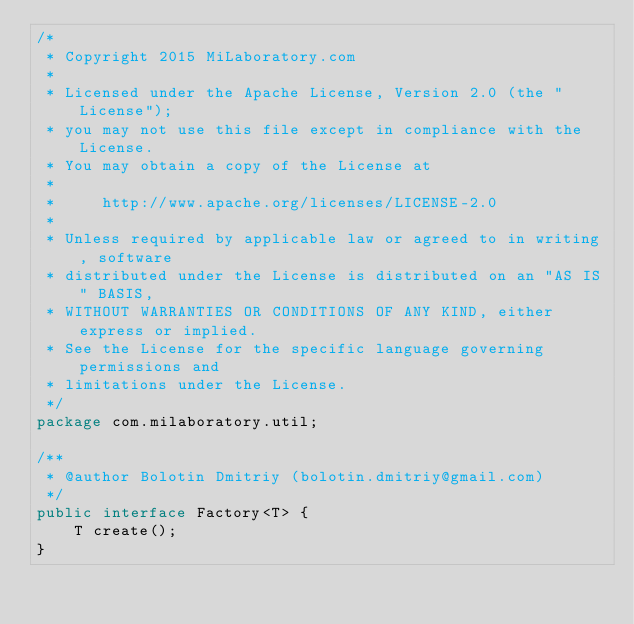Convert code to text. <code><loc_0><loc_0><loc_500><loc_500><_Java_>/*
 * Copyright 2015 MiLaboratory.com
 *
 * Licensed under the Apache License, Version 2.0 (the "License");
 * you may not use this file except in compliance with the License.
 * You may obtain a copy of the License at
 *
 *     http://www.apache.org/licenses/LICENSE-2.0
 *
 * Unless required by applicable law or agreed to in writing, software
 * distributed under the License is distributed on an "AS IS" BASIS,
 * WITHOUT WARRANTIES OR CONDITIONS OF ANY KIND, either express or implied.
 * See the License for the specific language governing permissions and
 * limitations under the License.
 */
package com.milaboratory.util;

/**
 * @author Bolotin Dmitriy (bolotin.dmitriy@gmail.com)
 */
public interface Factory<T> {
    T create();
}
</code> 